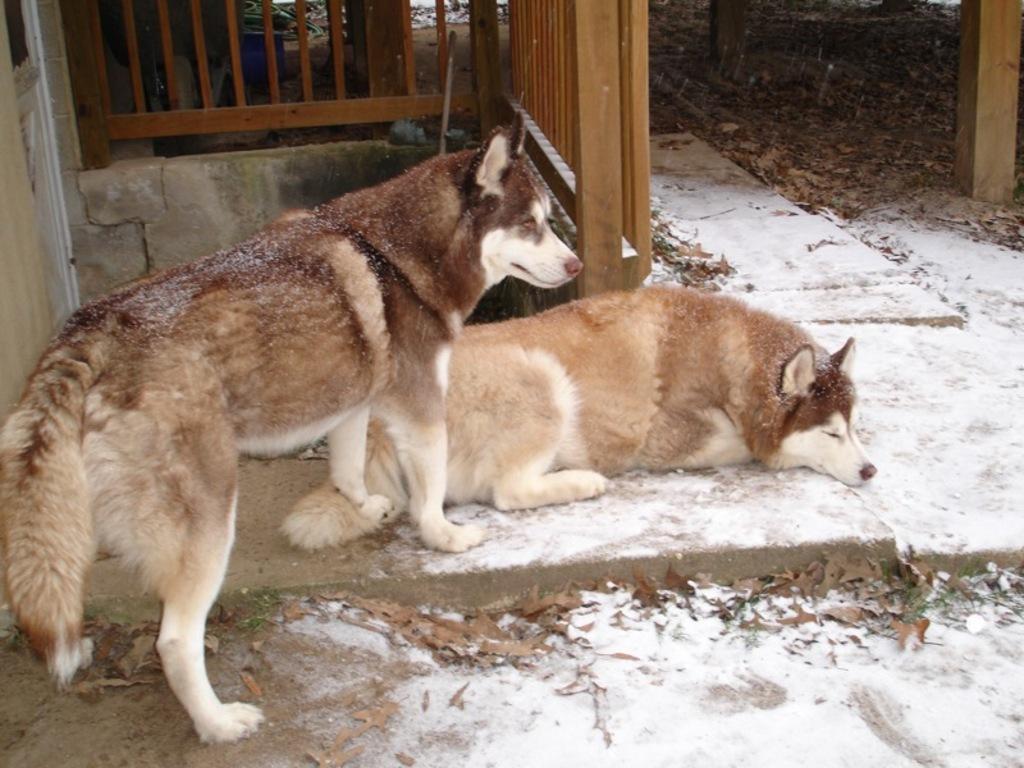Could you give a brief overview of what you see in this image? In this image there are two huskies one is standing the other is lying on the floor, the floor is covered with snow and leaves, in the background there is wooden fence. 